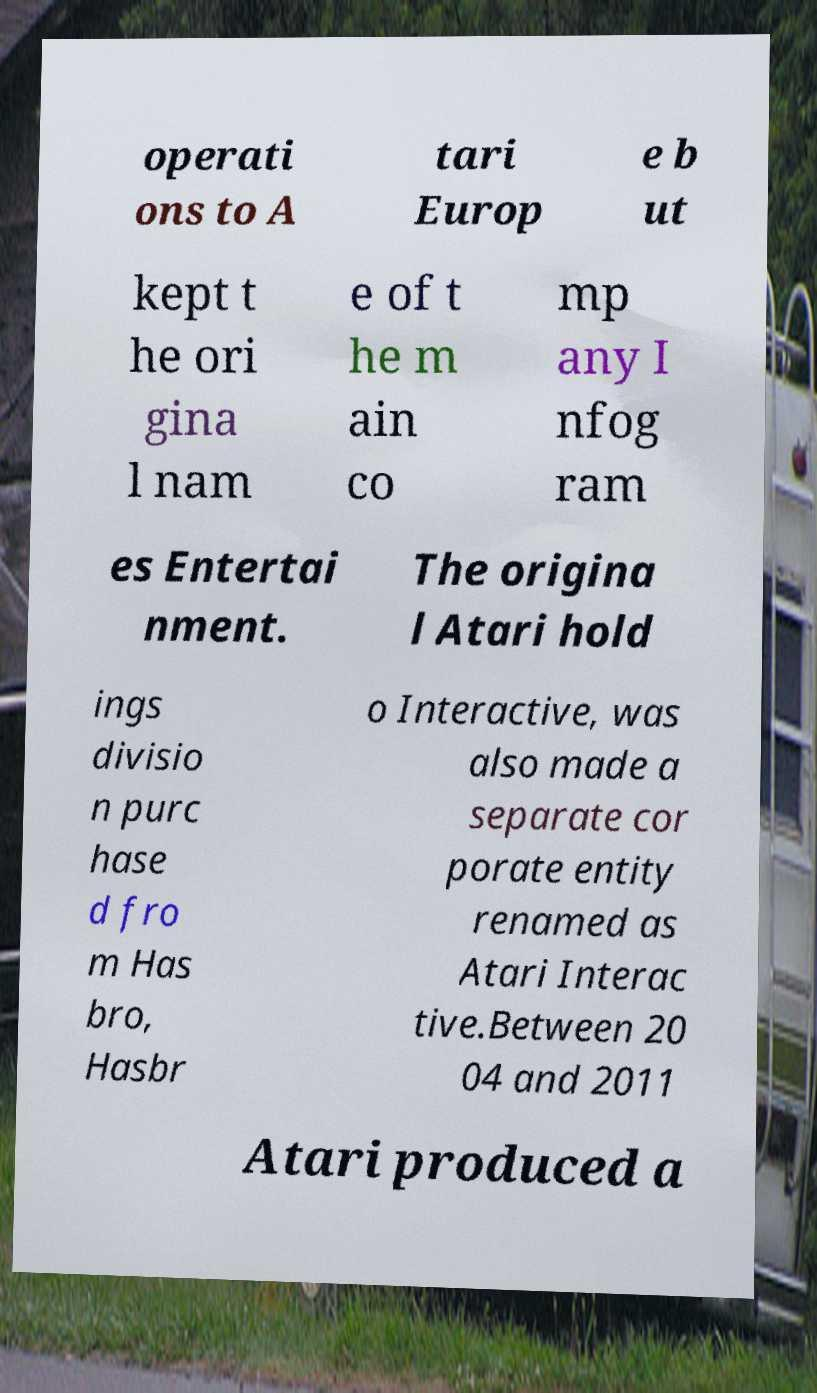There's text embedded in this image that I need extracted. Can you transcribe it verbatim? operati ons to A tari Europ e b ut kept t he ori gina l nam e of t he m ain co mp any I nfog ram es Entertai nment. The origina l Atari hold ings divisio n purc hase d fro m Has bro, Hasbr o Interactive, was also made a separate cor porate entity renamed as Atari Interac tive.Between 20 04 and 2011 Atari produced a 